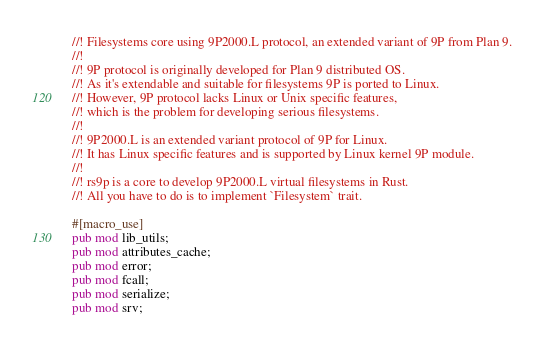<code> <loc_0><loc_0><loc_500><loc_500><_Rust_>//! Filesystems core using 9P2000.L protocol, an extended variant of 9P from Plan 9.
//!
//! 9P protocol is originally developed for Plan 9 distributed OS.
//! As it's extendable and suitable for filesystems 9P is ported to Linux.
//! However, 9P protocol lacks Linux or Unix specific features,
//! which is the problem for developing serious filesystems.
//!
//! 9P2000.L is an extended variant protocol of 9P for Linux.
//! It has Linux specific features and is supported by Linux kernel 9P module.
//!
//! rs9p is a core to develop 9P2000.L virtual filesystems in Rust.
//! All you have to do is to implement `Filesystem` trait.

#[macro_use]
pub mod lib_utils;
pub mod attributes_cache;
pub mod error;
pub mod fcall;
pub mod serialize;
pub mod srv;
</code> 